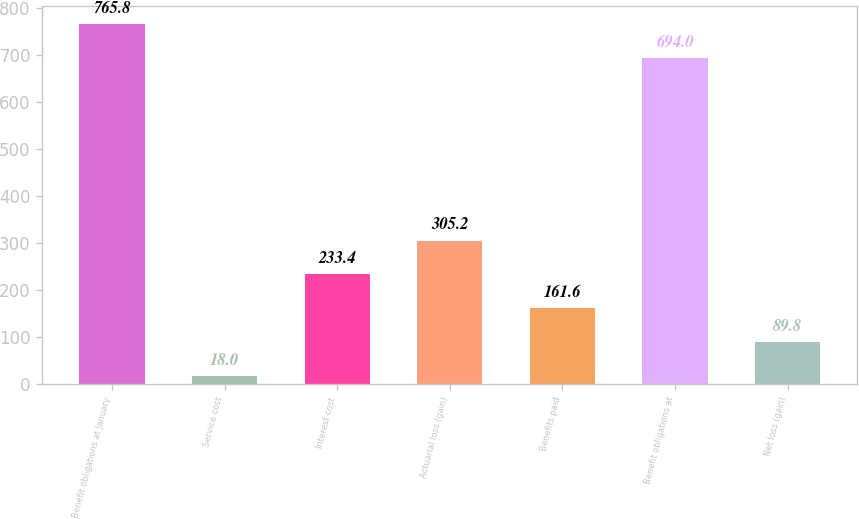Convert chart. <chart><loc_0><loc_0><loc_500><loc_500><bar_chart><fcel>Benefit obligations at January<fcel>Service cost<fcel>Interest cost<fcel>Actuarial loss (gain)<fcel>Benefits paid<fcel>Benefit obligations at<fcel>Net loss (gain)<nl><fcel>765.8<fcel>18<fcel>233.4<fcel>305.2<fcel>161.6<fcel>694<fcel>89.8<nl></chart> 